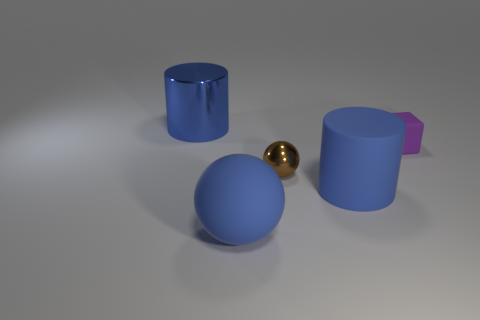Subtract all yellow cubes. Subtract all yellow cylinders. How many cubes are left? 1 Add 1 big blue objects. How many objects exist? 6 Subtract all blocks. How many objects are left? 4 Add 2 big blue metallic things. How many big blue metallic things are left? 3 Add 3 cyan shiny things. How many cyan shiny things exist? 3 Subtract 0 blue blocks. How many objects are left? 5 Subtract all blue matte things. Subtract all spheres. How many objects are left? 1 